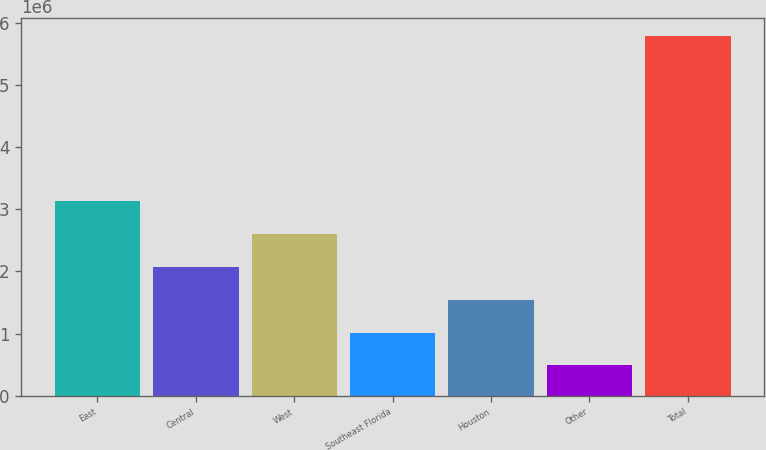<chart> <loc_0><loc_0><loc_500><loc_500><bar_chart><fcel>East<fcel>Central<fcel>West<fcel>Southeast Florida<fcel>Houston<fcel>Other<fcel>Total<nl><fcel>3.13572e+06<fcel>2.07571e+06<fcel>2.60572e+06<fcel>1.0157e+06<fcel>1.54571e+06<fcel>485699<fcel>5.78574e+06<nl></chart> 